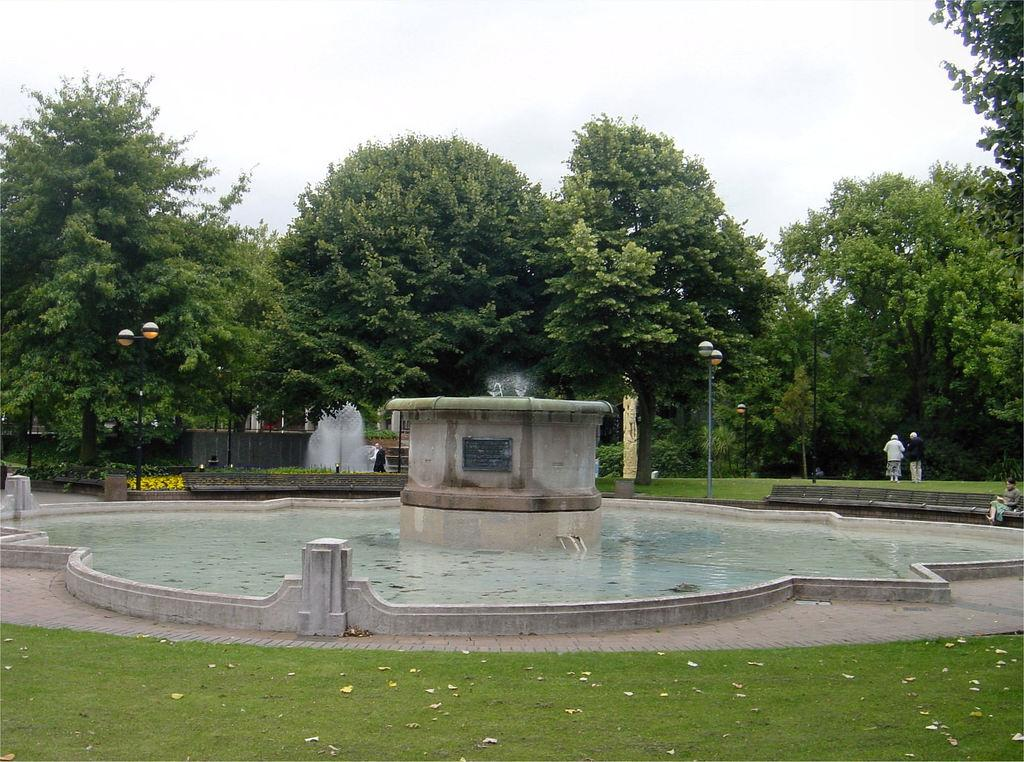What can be seen in the background of the image? In the background of the image, there are trees, plants, persons, lights with poles, and a sky. What is the main feature of the image? The main feature of the image is a water fountain. What type of vegetation is visible at the bottom of the image? Grass is visible at the bottom of the image. Can you tell me where the aunt and grandfather are sitting in the image? There is no aunt or grandfather present in the image. What type of train can be seen passing by the water fountain in the image? There is no train visible in the image; it features a water fountain, grass, and various elements in the background. 